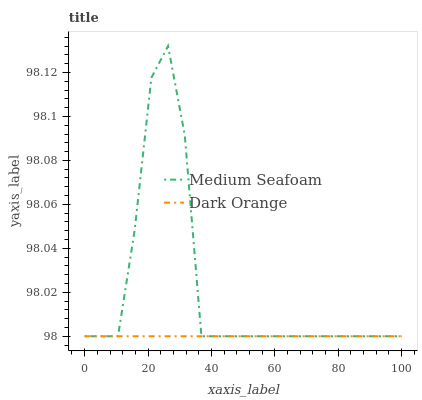Does Dark Orange have the minimum area under the curve?
Answer yes or no. Yes. Does Medium Seafoam have the maximum area under the curve?
Answer yes or no. Yes. Does Medium Seafoam have the minimum area under the curve?
Answer yes or no. No. Is Dark Orange the smoothest?
Answer yes or no. Yes. Is Medium Seafoam the roughest?
Answer yes or no. Yes. Is Medium Seafoam the smoothest?
Answer yes or no. No. Does Dark Orange have the lowest value?
Answer yes or no. Yes. Does Medium Seafoam have the highest value?
Answer yes or no. Yes. Does Medium Seafoam intersect Dark Orange?
Answer yes or no. Yes. Is Medium Seafoam less than Dark Orange?
Answer yes or no. No. Is Medium Seafoam greater than Dark Orange?
Answer yes or no. No. 